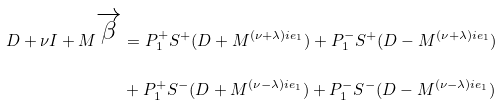Convert formula to latex. <formula><loc_0><loc_0><loc_500><loc_500>D + \nu I + M ^ { \overrightarrow { \beta } } & = P _ { 1 } ^ { + } S ^ { + } ( D + M ^ { ( \nu + \lambda ) i e _ { 1 } } ) + P _ { 1 } ^ { - } S ^ { + } ( D - M ^ { ( \nu + \lambda ) i e _ { 1 } } ) \\ & + P _ { 1 } ^ { + } S ^ { - } ( D + M ^ { ( \nu - \lambda ) i e _ { 1 } } ) + P _ { 1 } ^ { - } S ^ { - } ( D - M ^ { ( \nu - \lambda ) i e _ { 1 } } )</formula> 